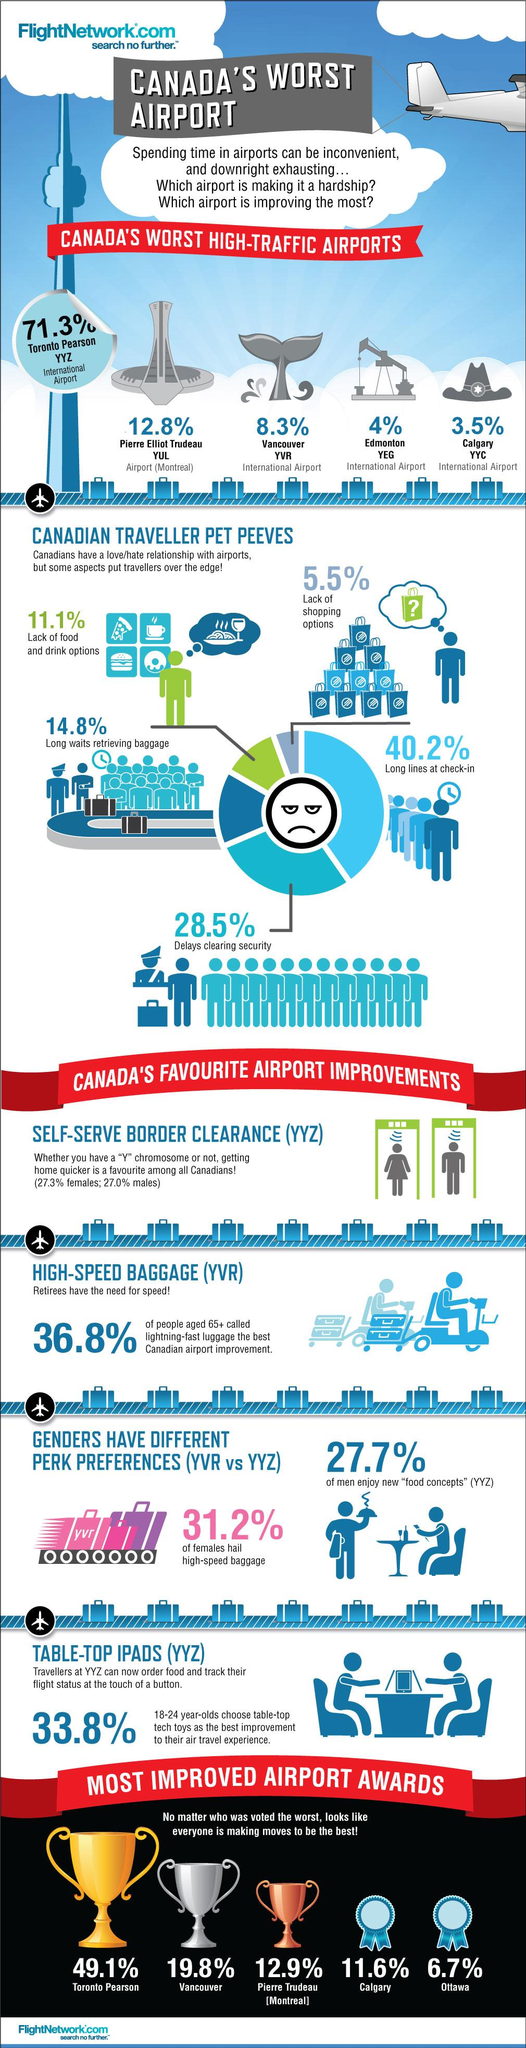Mention a couple of crucial points in this snapshot. Pierre Trudeau International Airport, located in Montreal, was voted the third best airport in the world. Delays in clearing security at airports are the second largest pet peeve among Canadians, according to a survey. According to the data, only 27.3% of women report liking the use of self-serve checkout options. Toronto Pearson Airport has been awarded the Golden Cup for improvement, highlighting the airport's commitment to enhancing its services and facilities. 